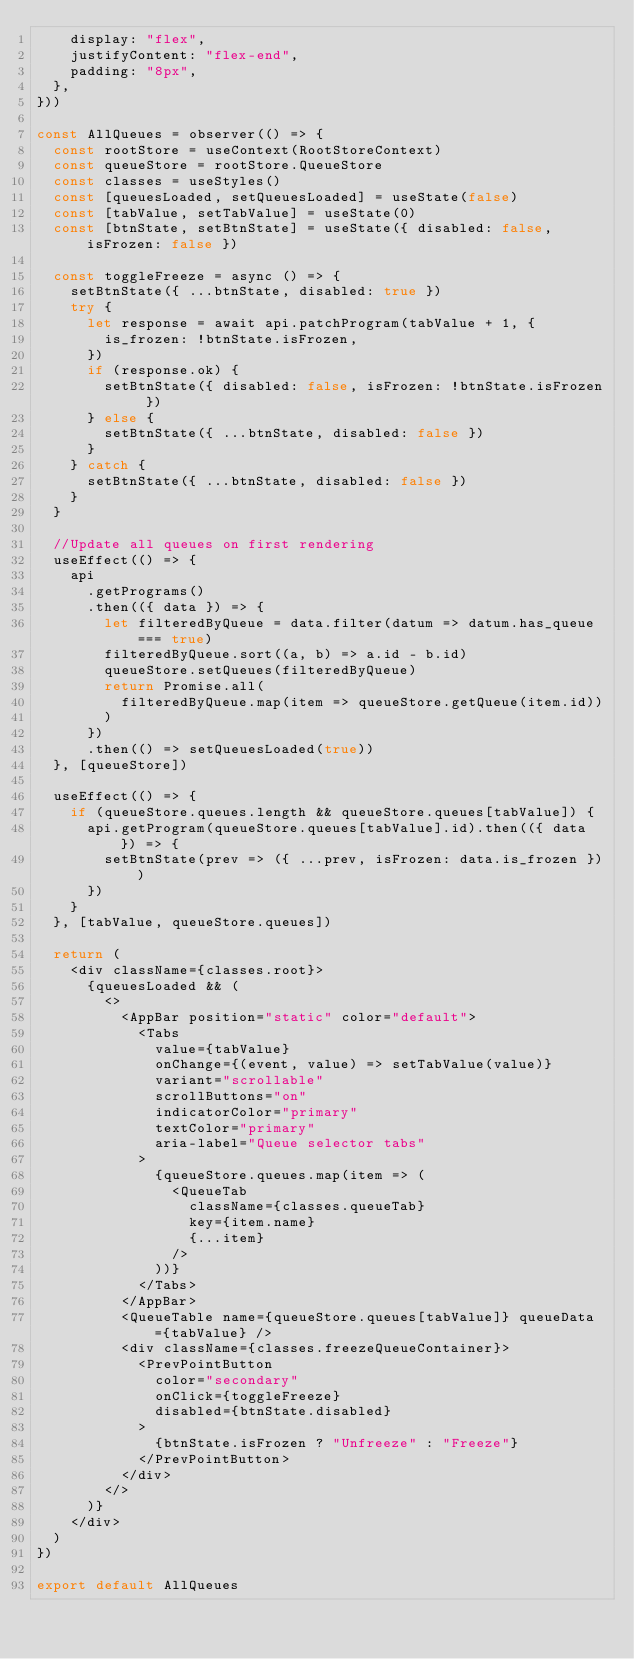Convert code to text. <code><loc_0><loc_0><loc_500><loc_500><_JavaScript_>    display: "flex",
    justifyContent: "flex-end",
    padding: "8px",
  },
}))

const AllQueues = observer(() => {
  const rootStore = useContext(RootStoreContext)
  const queueStore = rootStore.QueueStore
  const classes = useStyles()
  const [queuesLoaded, setQueuesLoaded] = useState(false)
  const [tabValue, setTabValue] = useState(0)
  const [btnState, setBtnState] = useState({ disabled: false, isFrozen: false })

  const toggleFreeze = async () => {
    setBtnState({ ...btnState, disabled: true })
    try {
      let response = await api.patchProgram(tabValue + 1, {
        is_frozen: !btnState.isFrozen,
      })
      if (response.ok) {
        setBtnState({ disabled: false, isFrozen: !btnState.isFrozen })
      } else {
        setBtnState({ ...btnState, disabled: false })
      }
    } catch {
      setBtnState({ ...btnState, disabled: false })
    }
  }

  //Update all queues on first rendering
  useEffect(() => {
    api
      .getPrograms()
      .then(({ data }) => {
        let filteredByQueue = data.filter(datum => datum.has_queue === true)
        filteredByQueue.sort((a, b) => a.id - b.id)
        queueStore.setQueues(filteredByQueue)
        return Promise.all(
          filteredByQueue.map(item => queueStore.getQueue(item.id))
        )
      })
      .then(() => setQueuesLoaded(true))
  }, [queueStore])

  useEffect(() => {
    if (queueStore.queues.length && queueStore.queues[tabValue]) {
      api.getProgram(queueStore.queues[tabValue].id).then(({ data }) => {
        setBtnState(prev => ({ ...prev, isFrozen: data.is_frozen }))
      })
    }
  }, [tabValue, queueStore.queues])

  return (
    <div className={classes.root}>
      {queuesLoaded && (
        <>
          <AppBar position="static" color="default">
            <Tabs
              value={tabValue}
              onChange={(event, value) => setTabValue(value)}
              variant="scrollable"
              scrollButtons="on"
              indicatorColor="primary"
              textColor="primary"
              aria-label="Queue selector tabs"
            >
              {queueStore.queues.map(item => (
                <QueueTab
                  className={classes.queueTab}
                  key={item.name}
                  {...item}
                />
              ))}
            </Tabs>
          </AppBar>
          <QueueTable name={queueStore.queues[tabValue]} queueData={tabValue} />
          <div className={classes.freezeQueueContainer}>
            <PrevPointButton
              color="secondary"
              onClick={toggleFreeze}
              disabled={btnState.disabled}
            >
              {btnState.isFrozen ? "Unfreeze" : "Freeze"}
            </PrevPointButton>
          </div>
        </>
      )}
    </div>
  )
})

export default AllQueues
</code> 